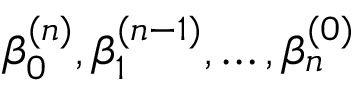Convert formula to latex. <formula><loc_0><loc_0><loc_500><loc_500>\beta _ { 0 } ^ { ( n ) } , \beta _ { 1 } ^ { ( n - 1 ) } , \dots , \beta _ { n } ^ { ( 0 ) }</formula> 